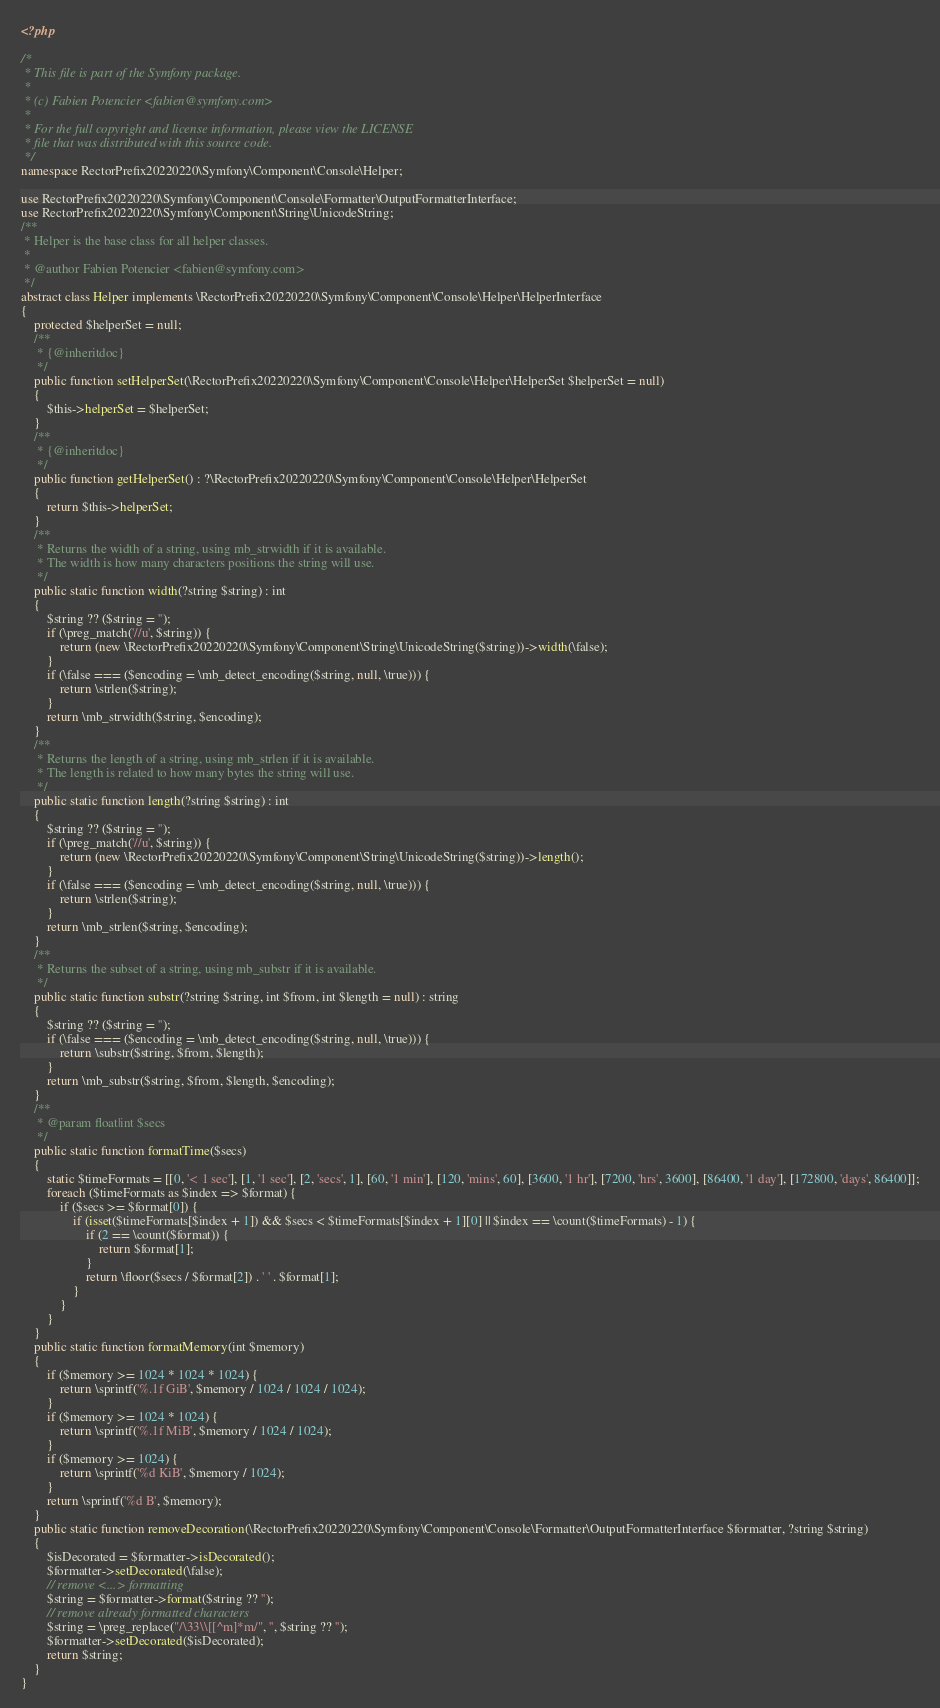<code> <loc_0><loc_0><loc_500><loc_500><_PHP_><?php

/*
 * This file is part of the Symfony package.
 *
 * (c) Fabien Potencier <fabien@symfony.com>
 *
 * For the full copyright and license information, please view the LICENSE
 * file that was distributed with this source code.
 */
namespace RectorPrefix20220220\Symfony\Component\Console\Helper;

use RectorPrefix20220220\Symfony\Component\Console\Formatter\OutputFormatterInterface;
use RectorPrefix20220220\Symfony\Component\String\UnicodeString;
/**
 * Helper is the base class for all helper classes.
 *
 * @author Fabien Potencier <fabien@symfony.com>
 */
abstract class Helper implements \RectorPrefix20220220\Symfony\Component\Console\Helper\HelperInterface
{
    protected $helperSet = null;
    /**
     * {@inheritdoc}
     */
    public function setHelperSet(\RectorPrefix20220220\Symfony\Component\Console\Helper\HelperSet $helperSet = null)
    {
        $this->helperSet = $helperSet;
    }
    /**
     * {@inheritdoc}
     */
    public function getHelperSet() : ?\RectorPrefix20220220\Symfony\Component\Console\Helper\HelperSet
    {
        return $this->helperSet;
    }
    /**
     * Returns the width of a string, using mb_strwidth if it is available.
     * The width is how many characters positions the string will use.
     */
    public static function width(?string $string) : int
    {
        $string ?? ($string = '');
        if (\preg_match('//u', $string)) {
            return (new \RectorPrefix20220220\Symfony\Component\String\UnicodeString($string))->width(\false);
        }
        if (\false === ($encoding = \mb_detect_encoding($string, null, \true))) {
            return \strlen($string);
        }
        return \mb_strwidth($string, $encoding);
    }
    /**
     * Returns the length of a string, using mb_strlen if it is available.
     * The length is related to how many bytes the string will use.
     */
    public static function length(?string $string) : int
    {
        $string ?? ($string = '');
        if (\preg_match('//u', $string)) {
            return (new \RectorPrefix20220220\Symfony\Component\String\UnicodeString($string))->length();
        }
        if (\false === ($encoding = \mb_detect_encoding($string, null, \true))) {
            return \strlen($string);
        }
        return \mb_strlen($string, $encoding);
    }
    /**
     * Returns the subset of a string, using mb_substr if it is available.
     */
    public static function substr(?string $string, int $from, int $length = null) : string
    {
        $string ?? ($string = '');
        if (\false === ($encoding = \mb_detect_encoding($string, null, \true))) {
            return \substr($string, $from, $length);
        }
        return \mb_substr($string, $from, $length, $encoding);
    }
    /**
     * @param float|int $secs
     */
    public static function formatTime($secs)
    {
        static $timeFormats = [[0, '< 1 sec'], [1, '1 sec'], [2, 'secs', 1], [60, '1 min'], [120, 'mins', 60], [3600, '1 hr'], [7200, 'hrs', 3600], [86400, '1 day'], [172800, 'days', 86400]];
        foreach ($timeFormats as $index => $format) {
            if ($secs >= $format[0]) {
                if (isset($timeFormats[$index + 1]) && $secs < $timeFormats[$index + 1][0] || $index == \count($timeFormats) - 1) {
                    if (2 == \count($format)) {
                        return $format[1];
                    }
                    return \floor($secs / $format[2]) . ' ' . $format[1];
                }
            }
        }
    }
    public static function formatMemory(int $memory)
    {
        if ($memory >= 1024 * 1024 * 1024) {
            return \sprintf('%.1f GiB', $memory / 1024 / 1024 / 1024);
        }
        if ($memory >= 1024 * 1024) {
            return \sprintf('%.1f MiB', $memory / 1024 / 1024);
        }
        if ($memory >= 1024) {
            return \sprintf('%d KiB', $memory / 1024);
        }
        return \sprintf('%d B', $memory);
    }
    public static function removeDecoration(\RectorPrefix20220220\Symfony\Component\Console\Formatter\OutputFormatterInterface $formatter, ?string $string)
    {
        $isDecorated = $formatter->isDecorated();
        $formatter->setDecorated(\false);
        // remove <...> formatting
        $string = $formatter->format($string ?? '');
        // remove already formatted characters
        $string = \preg_replace("/\33\\[[^m]*m/", '', $string ?? '');
        $formatter->setDecorated($isDecorated);
        return $string;
    }
}
</code> 